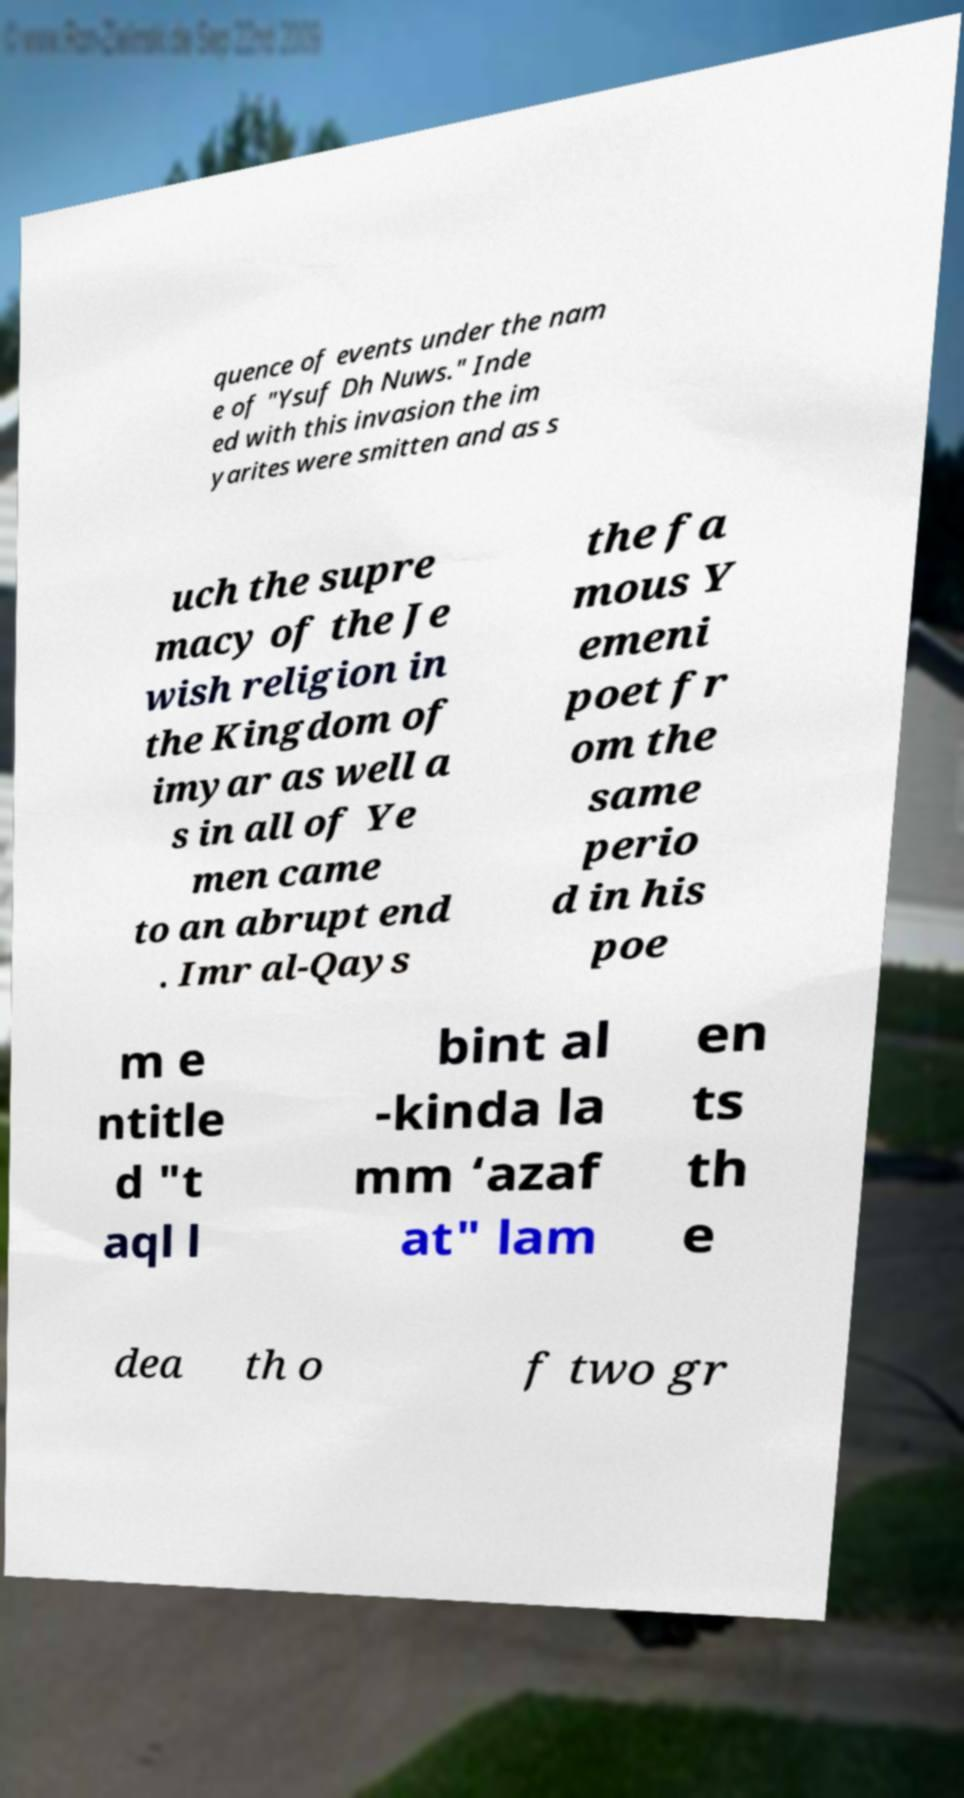I need the written content from this picture converted into text. Can you do that? quence of events under the nam e of "Ysuf Dh Nuws." Inde ed with this invasion the im yarites were smitten and as s uch the supre macy of the Je wish religion in the Kingdom of imyar as well a s in all of Ye men came to an abrupt end . Imr al-Qays the fa mous Y emeni poet fr om the same perio d in his poe m e ntitle d "t aql l bint al -kinda la mm ‘azaf at" lam en ts th e dea th o f two gr 